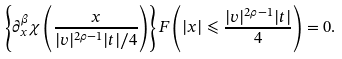<formula> <loc_0><loc_0><loc_500><loc_500>\left \{ \partial _ { x } ^ { \beta } \chi \left ( \frac { x } { | v | ^ { 2 \rho - 1 } | t | / 4 } \right ) \right \} F \left ( | x | \leqslant \frac { | v | ^ { 2 \rho - 1 } | t | } { 4 } \right ) = 0 .</formula> 